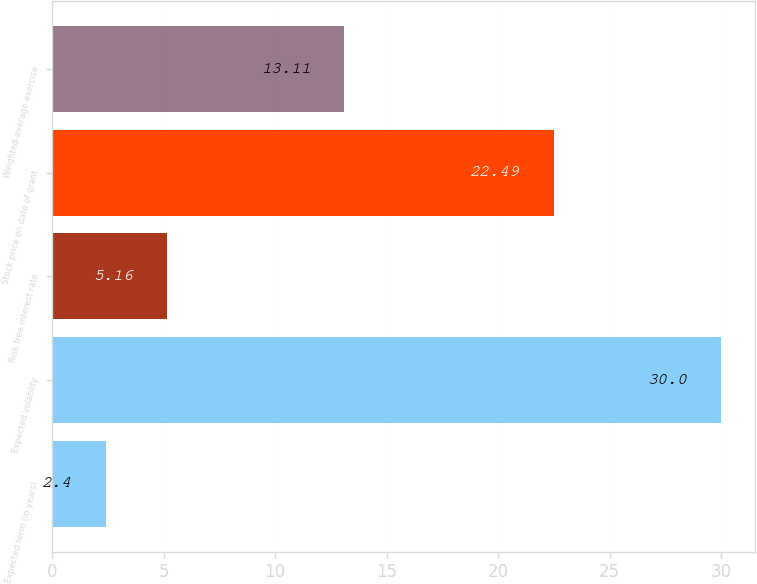Convert chart to OTSL. <chart><loc_0><loc_0><loc_500><loc_500><bar_chart><fcel>Expected term (in years)<fcel>Expected volatility<fcel>Risk free interest rate<fcel>Stock price on date of grant<fcel>Weighted-average exercise<nl><fcel>2.4<fcel>30<fcel>5.16<fcel>22.49<fcel>13.11<nl></chart> 